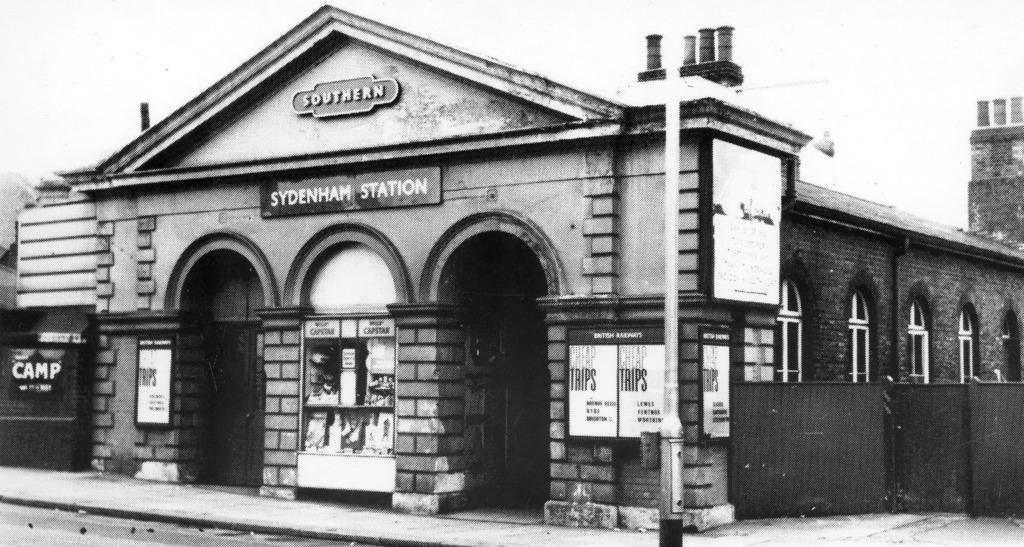Can you describe this image briefly? This is a black and white picture and in this picture we can see the footpath, pole, name boards, posters, building with windows and some objects. 